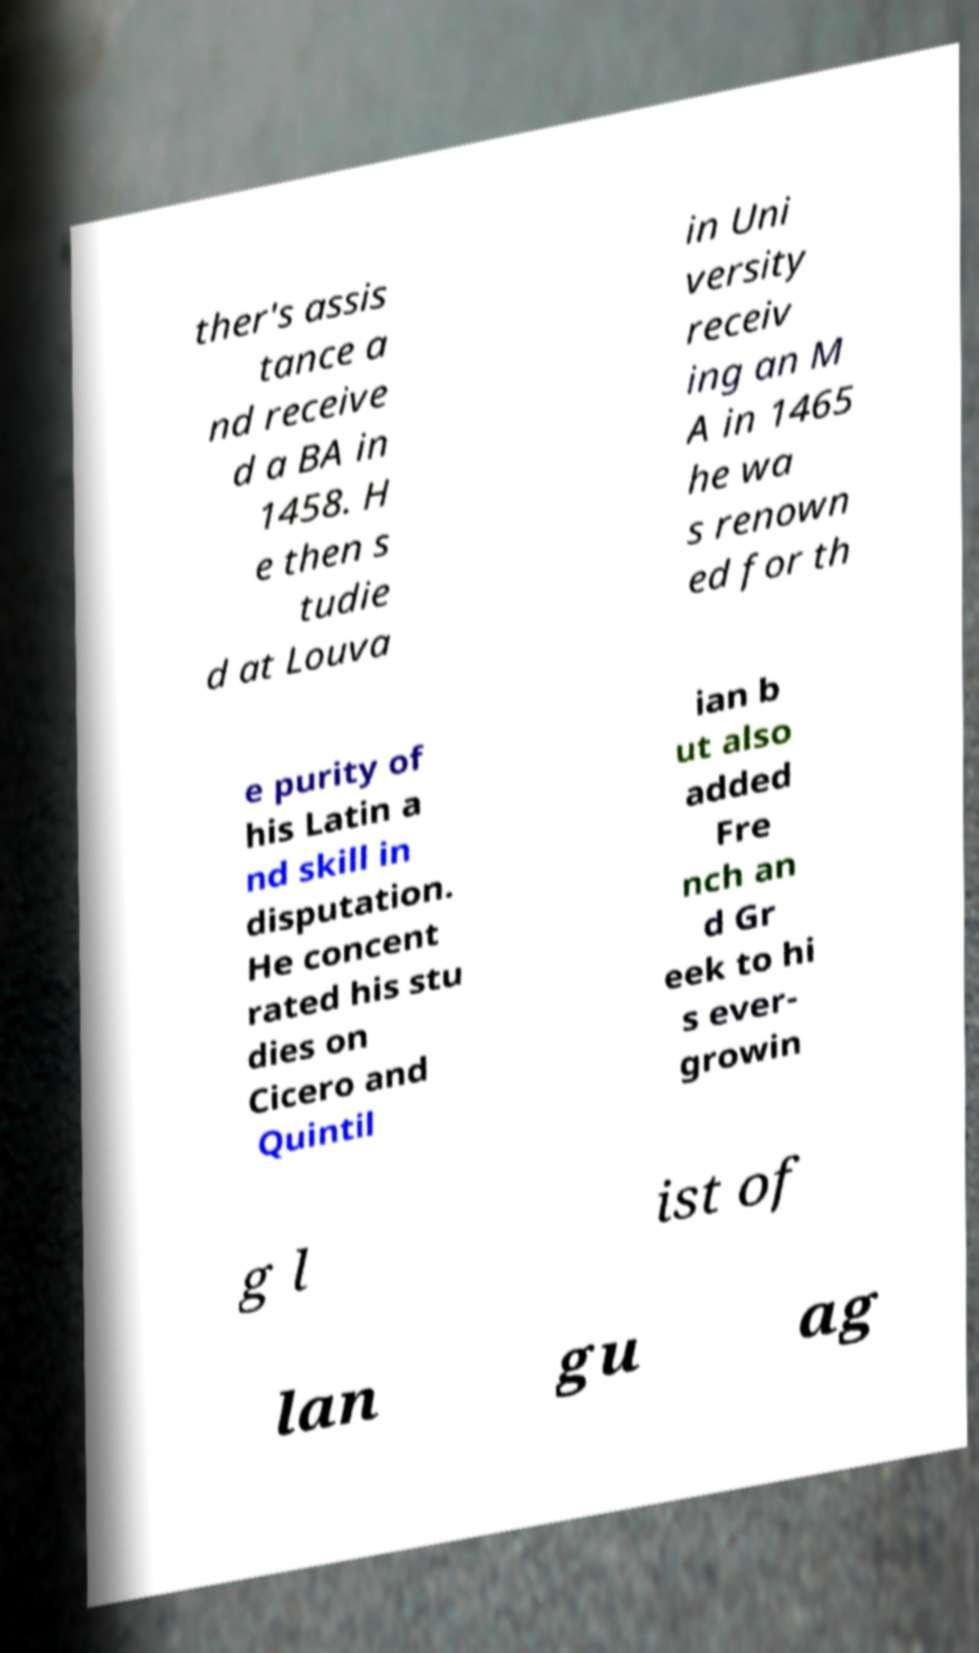Please identify and transcribe the text found in this image. ther's assis tance a nd receive d a BA in 1458. H e then s tudie d at Louva in Uni versity receiv ing an M A in 1465 he wa s renown ed for th e purity of his Latin a nd skill in disputation. He concent rated his stu dies on Cicero and Quintil ian b ut also added Fre nch an d Gr eek to hi s ever- growin g l ist of lan gu ag 